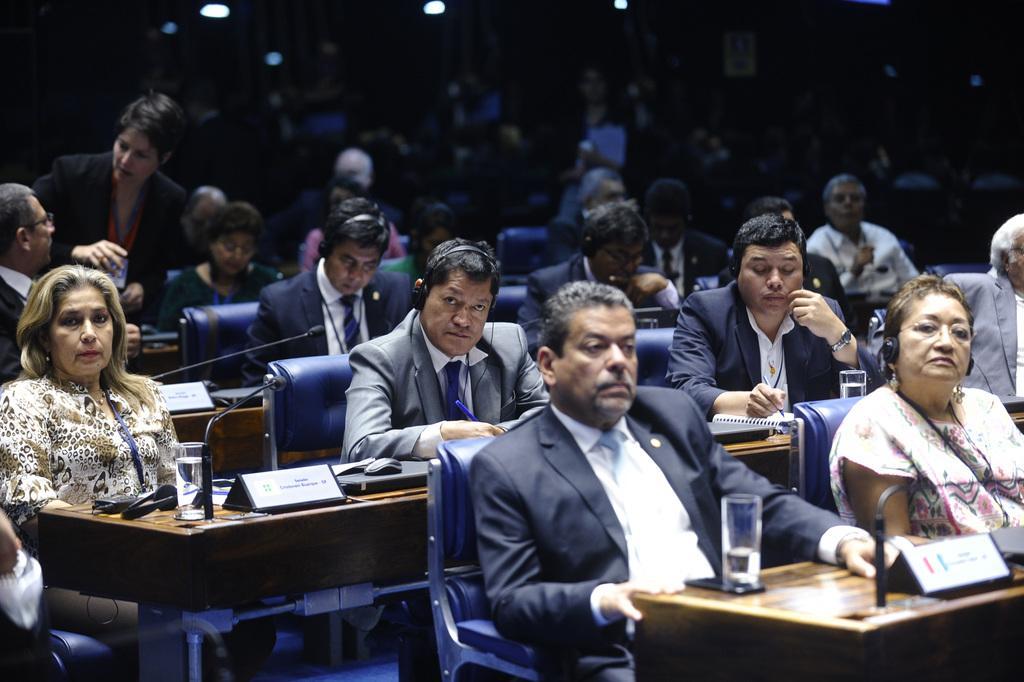In one or two sentences, can you explain what this image depicts? There is a room. There is a group of people. They are sitting on a chairs. On the left side we have a woman. She is standing. She is holding a glass. There is a table. There is a glass,file,headphones,microphone on a table. In the center we have a person. He is wearing a headphones. 